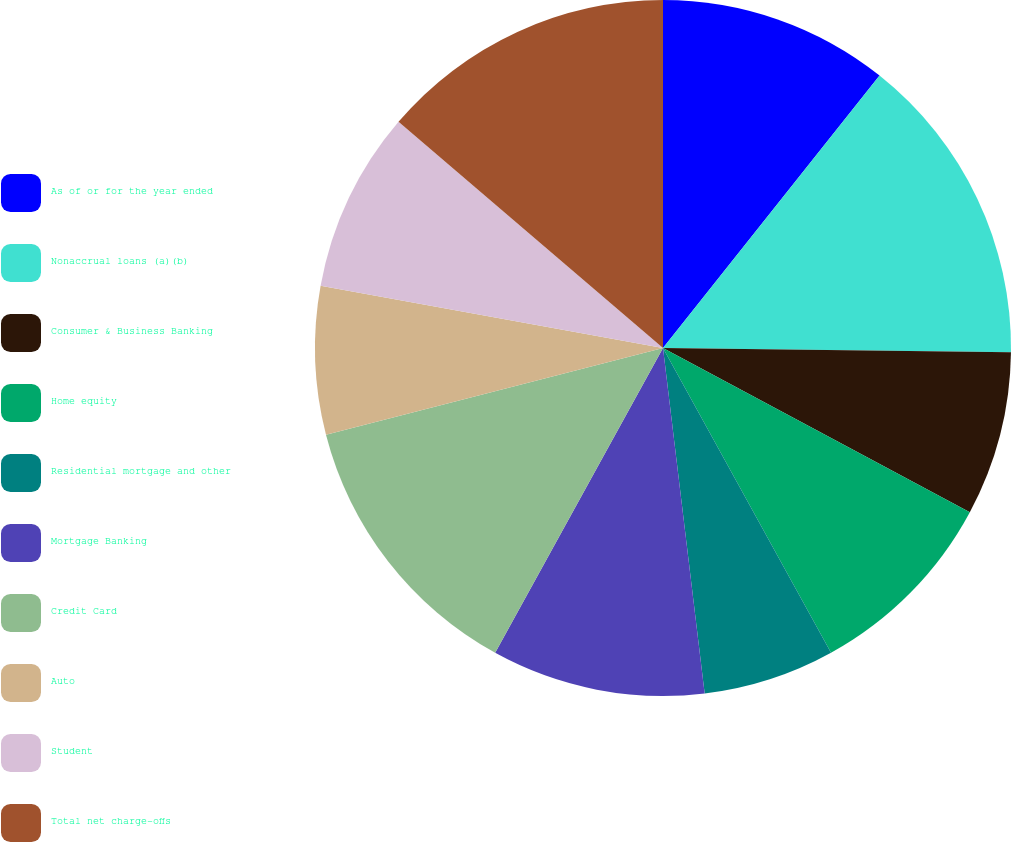<chart> <loc_0><loc_0><loc_500><loc_500><pie_chart><fcel>As of or for the year ended<fcel>Nonaccrual loans (a)(b)<fcel>Consumer & Business Banking<fcel>Home equity<fcel>Residential mortgage and other<fcel>Mortgage Banking<fcel>Credit Card<fcel>Auto<fcel>Student<fcel>Total net charge-offs<nl><fcel>10.69%<fcel>14.5%<fcel>7.63%<fcel>9.16%<fcel>6.11%<fcel>9.92%<fcel>12.98%<fcel>6.87%<fcel>8.4%<fcel>13.74%<nl></chart> 